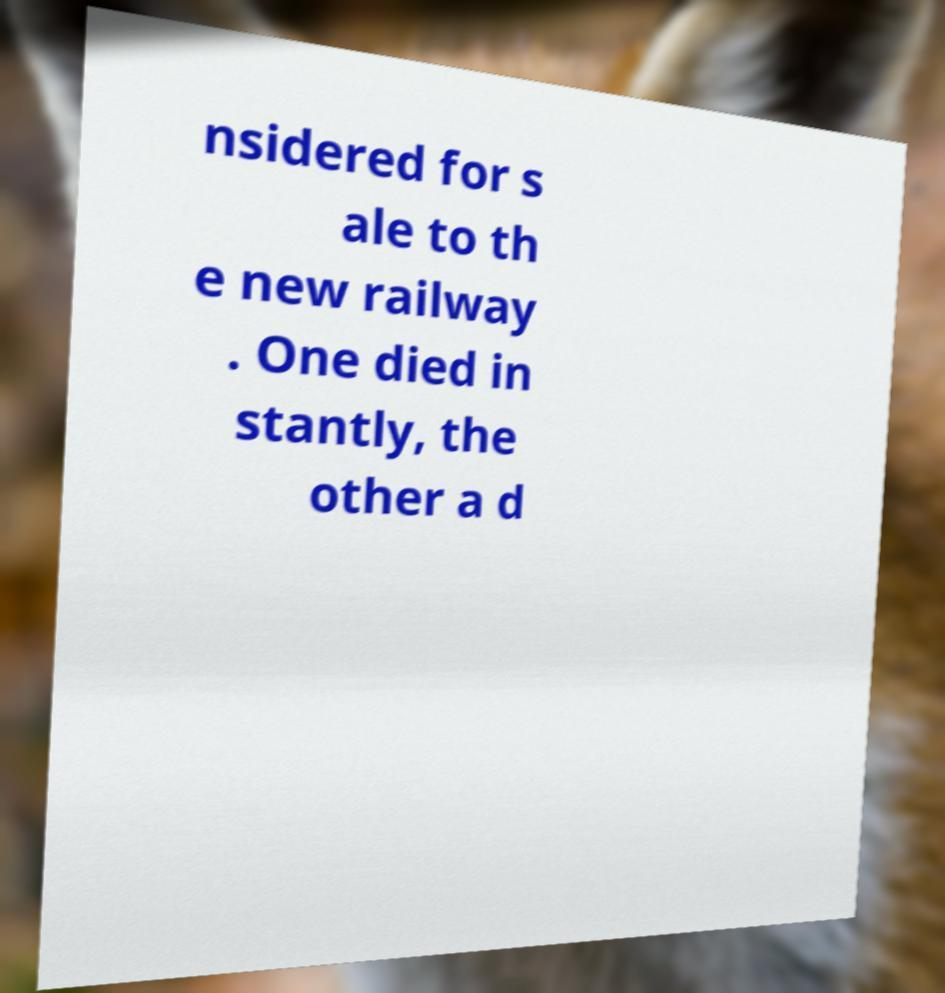I need the written content from this picture converted into text. Can you do that? nsidered for s ale to th e new railway . One died in stantly, the other a d 